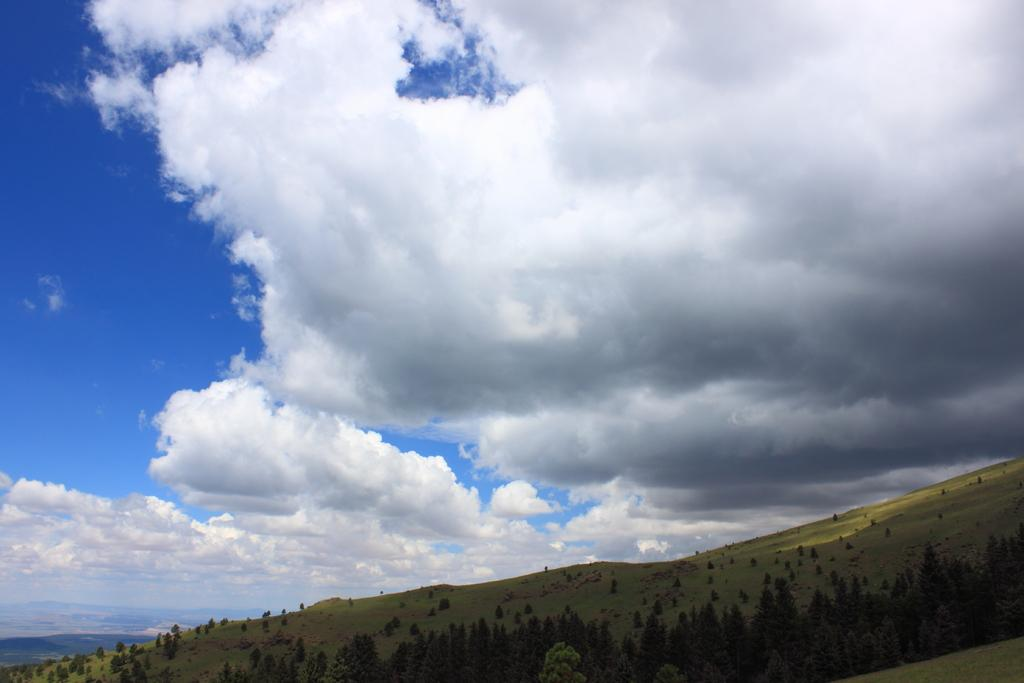What type of vegetation is present on the ground in the image? There are trees on the ground in the image. What can be seen in the sky in the background of the image? There are clouds visible in the background of the image. What color is the sky in the background of the image? The sky is blue in the background of the image. What type of pencil is being used to draw the clouds in the image? There is no pencil or drawing activity present in the image; it is a photograph of trees and clouds. What guide is being used to create the blue sky in the image? There is no guide present in the image; the blue sky is a natural occurrence. 